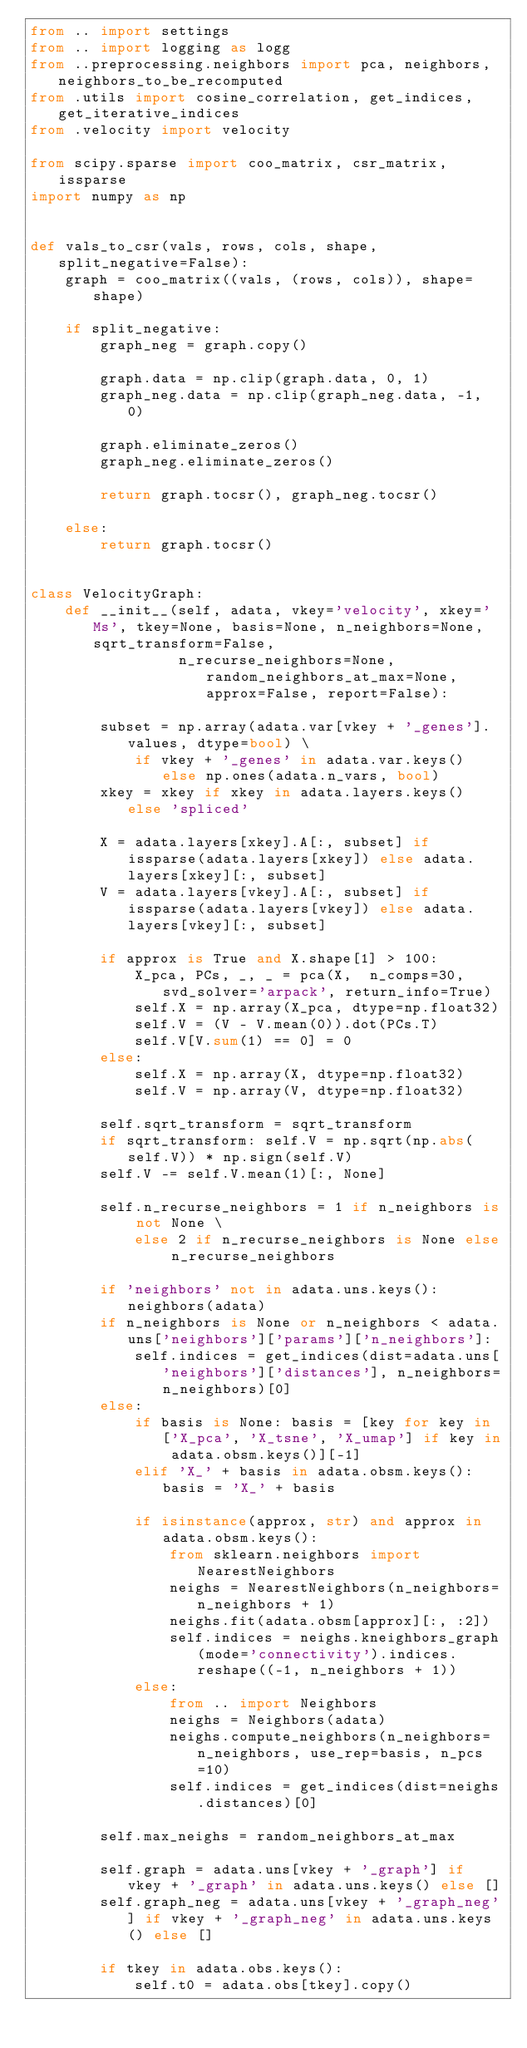Convert code to text. <code><loc_0><loc_0><loc_500><loc_500><_Python_>from .. import settings
from .. import logging as logg
from ..preprocessing.neighbors import pca, neighbors, neighbors_to_be_recomputed
from .utils import cosine_correlation, get_indices, get_iterative_indices
from .velocity import velocity

from scipy.sparse import coo_matrix, csr_matrix, issparse
import numpy as np


def vals_to_csr(vals, rows, cols, shape, split_negative=False):
    graph = coo_matrix((vals, (rows, cols)), shape=shape)

    if split_negative:
        graph_neg = graph.copy()

        graph.data = np.clip(graph.data, 0, 1)
        graph_neg.data = np.clip(graph_neg.data, -1, 0)

        graph.eliminate_zeros()
        graph_neg.eliminate_zeros()

        return graph.tocsr(), graph_neg.tocsr()

    else:
        return graph.tocsr()


class VelocityGraph:
    def __init__(self, adata, vkey='velocity', xkey='Ms', tkey=None, basis=None, n_neighbors=None, sqrt_transform=False,
                 n_recurse_neighbors=None, random_neighbors_at_max=None, approx=False, report=False):

        subset = np.array(adata.var[vkey + '_genes'].values, dtype=bool) \
            if vkey + '_genes' in adata.var.keys() else np.ones(adata.n_vars, bool)
        xkey = xkey if xkey in adata.layers.keys() else 'spliced'

        X = adata.layers[xkey].A[:, subset] if issparse(adata.layers[xkey]) else adata.layers[xkey][:, subset]
        V = adata.layers[vkey].A[:, subset] if issparse(adata.layers[vkey]) else adata.layers[vkey][:, subset]

        if approx is True and X.shape[1] > 100:
            X_pca, PCs, _, _ = pca(X,  n_comps=30, svd_solver='arpack', return_info=True)
            self.X = np.array(X_pca, dtype=np.float32)
            self.V = (V - V.mean(0)).dot(PCs.T)
            self.V[V.sum(1) == 0] = 0
        else:
            self.X = np.array(X, dtype=np.float32)
            self.V = np.array(V, dtype=np.float32)

        self.sqrt_transform = sqrt_transform
        if sqrt_transform: self.V = np.sqrt(np.abs(self.V)) * np.sign(self.V)
        self.V -= self.V.mean(1)[:, None]

        self.n_recurse_neighbors = 1 if n_neighbors is not None \
            else 2 if n_recurse_neighbors is None else n_recurse_neighbors

        if 'neighbors' not in adata.uns.keys(): neighbors(adata)
        if n_neighbors is None or n_neighbors < adata.uns['neighbors']['params']['n_neighbors']:
            self.indices = get_indices(dist=adata.uns['neighbors']['distances'], n_neighbors=n_neighbors)[0]
        else:
            if basis is None: basis = [key for key in ['X_pca', 'X_tsne', 'X_umap'] if key in adata.obsm.keys()][-1]
            elif 'X_' + basis in adata.obsm.keys(): basis = 'X_' + basis

            if isinstance(approx, str) and approx in adata.obsm.keys():
                from sklearn.neighbors import NearestNeighbors
                neighs = NearestNeighbors(n_neighbors=n_neighbors + 1)
                neighs.fit(adata.obsm[approx][:, :2])
                self.indices = neighs.kneighbors_graph(mode='connectivity').indices.reshape((-1, n_neighbors + 1))
            else:
                from .. import Neighbors
                neighs = Neighbors(adata)
                neighs.compute_neighbors(n_neighbors=n_neighbors, use_rep=basis, n_pcs=10)
                self.indices = get_indices(dist=neighs.distances)[0]

        self.max_neighs = random_neighbors_at_max

        self.graph = adata.uns[vkey + '_graph'] if vkey + '_graph' in adata.uns.keys() else []
        self.graph_neg = adata.uns[vkey + '_graph_neg'] if vkey + '_graph_neg' in adata.uns.keys() else []

        if tkey in adata.obs.keys():
            self.t0 = adata.obs[tkey].copy()</code> 